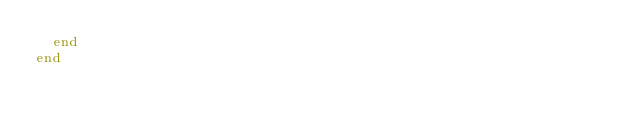Convert code to text. <code><loc_0><loc_0><loc_500><loc_500><_Ruby_>  end
end
</code> 